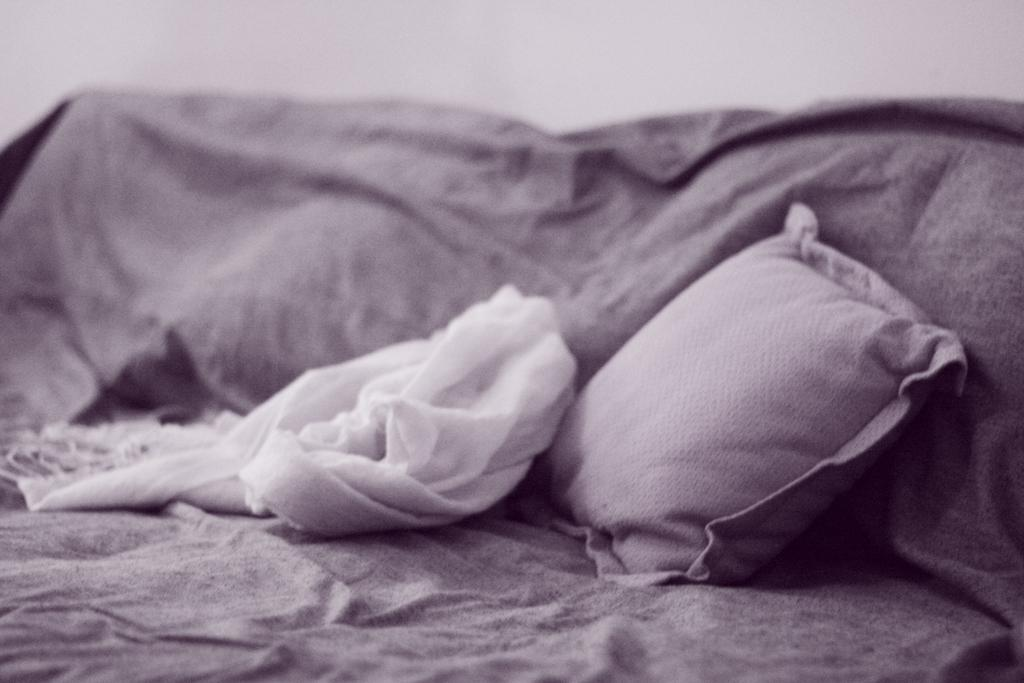What object can be seen in the image that is typically used for comfort? There is a pillow in the image that is typically used for comfort. What other item is present in the image that is related to the pillow? There is a white color stole beside the pillow. What type of feast is being prepared on the pillow in the image? There is no feast being prepared on the pillow in the image; it is a pillow with a white color stole beside it. 